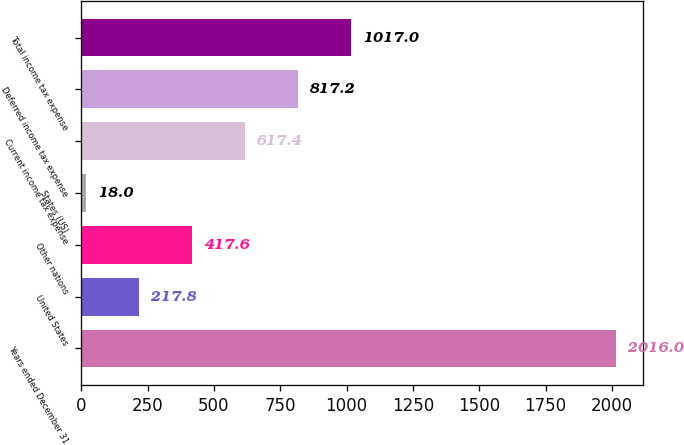<chart> <loc_0><loc_0><loc_500><loc_500><bar_chart><fcel>Years ended December 31<fcel>United States<fcel>Other nations<fcel>States (US)<fcel>Current income tax expense<fcel>Deferred income tax expense<fcel>Total income tax expense<nl><fcel>2016<fcel>217.8<fcel>417.6<fcel>18<fcel>617.4<fcel>817.2<fcel>1017<nl></chart> 